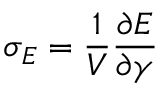<formula> <loc_0><loc_0><loc_500><loc_500>\sigma _ { E } = \frac { 1 } { V } \frac { \partial E } { \partial \gamma }</formula> 